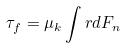Convert formula to latex. <formula><loc_0><loc_0><loc_500><loc_500>\tau _ { f } = \mu _ { k } \int r d F _ { n }</formula> 